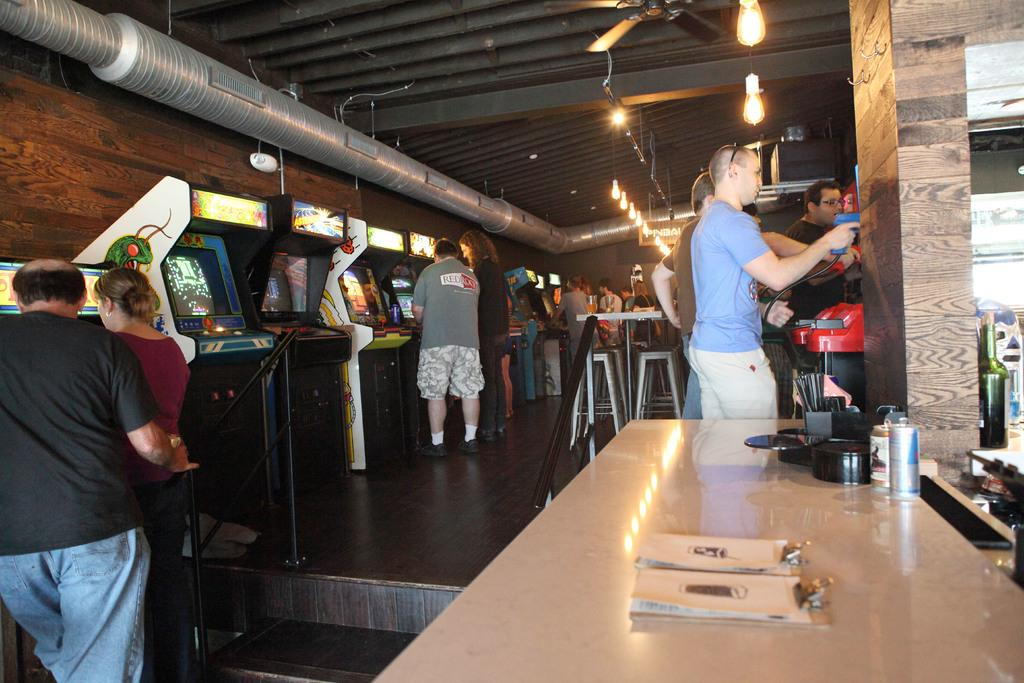How many people are in the image? There is a group of people in the image, but the exact number is not specified. What are the people in the image doing? The people are standing in front of a gaming box. Can you describe the gaming box in the image? Unfortunately, the facts provided do not give any details about the gaming box. What type of bone is being used as a pickle in the image? There is no bone or pickle present in the image. How many pigs are visible in the image? There is no mention of pigs in the image. 